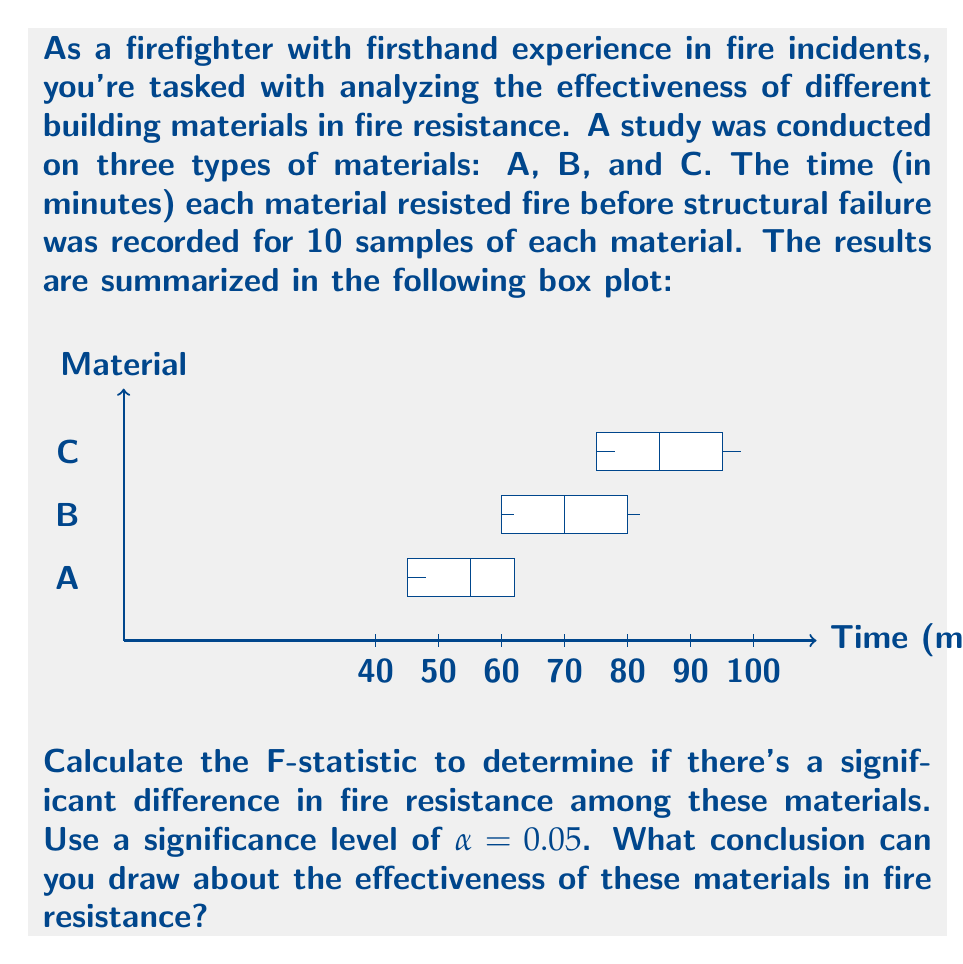Give your solution to this math problem. To calculate the F-statistic and determine if there's a significant difference in fire resistance among the materials, we'll use one-way ANOVA (Analysis of Variance). Let's go through this step-by-step:

1) First, we need to calculate the means and variances for each group:

   Material A: $\bar{x}_A = 54$, $s^2_A = 25$
   Material B: $\bar{x}_B = 71.2$, $s^2_B = 49$
   Material C: $\bar{x}_C = 86.3$, $s^2_C = 64$

2) Calculate the overall mean:
   $$\bar{x} = \frac{54 + 71.2 + 86.3}{3} = 70.5$$

3) Calculate SSB (Sum of Squares Between groups):
   $$SSB = 10[(54-70.5)^2 + (71.2-70.5)^2 + (86.3-70.5)^2] = 5184.7$$

4) Calculate SSW (Sum of Squares Within groups):
   $$SSW = 9(25 + 49 + 64) = 1242$$

5) Calculate MSB (Mean Square Between) and MSW (Mean Square Within):
   $$MSB = \frac{SSB}{k-1} = \frac{5184.7}{2} = 2592.35$$
   $$MSW = \frac{SSW}{N-k} = \frac{1242}{27} = 46$$

   Where k is the number of groups (3) and N is the total number of samples (30).

6) Calculate the F-statistic:
   $$F = \frac{MSB}{MSW} = \frac{2592.35}{46} = 56.36$$

7) Find the critical F-value:
   For $\alpha = 0.05$, with df1 = 2 and df2 = 27, the critical F-value is approximately 3.35.

8) Compare the calculated F-statistic to the critical F-value:
   56.36 > 3.35, so we reject the null hypothesis.

Conclusion: There is strong evidence of a significant difference in fire resistance among these materials. The F-statistic (56.36) far exceeds the critical value (3.35), indicating that the variation between groups is much larger than what we'd expect by chance. Material C appears to have the highest fire resistance, followed by B, then A.
Answer: F(2,27) = 56.36, p < 0.05. Significant difference in fire resistance among materials. 